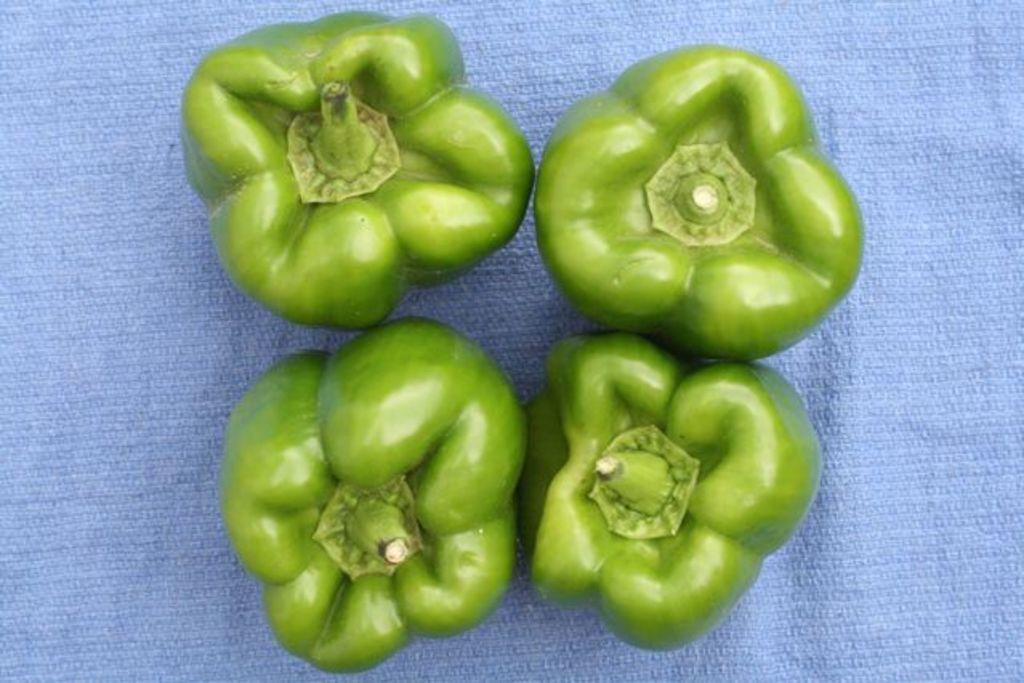Can you describe this image briefly? In this picture we can see few vegetables are placed on the blue color cloth. 